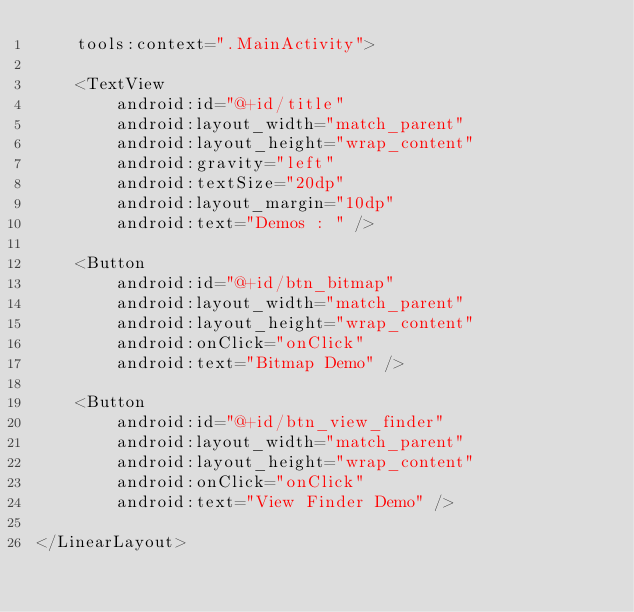<code> <loc_0><loc_0><loc_500><loc_500><_XML_>    tools:context=".MainActivity">

    <TextView
        android:id="@+id/title"
        android:layout_width="match_parent"
        android:layout_height="wrap_content"
        android:gravity="left"
        android:textSize="20dp"
        android:layout_margin="10dp"
        android:text="Demos : " />

    <Button
        android:id="@+id/btn_bitmap"
        android:layout_width="match_parent"
        android:layout_height="wrap_content"
        android:onClick="onClick"
        android:text="Bitmap Demo" />

    <Button
        android:id="@+id/btn_view_finder"
        android:layout_width="match_parent"
        android:layout_height="wrap_content"
        android:onClick="onClick"
        android:text="View Finder Demo" />

</LinearLayout></code> 